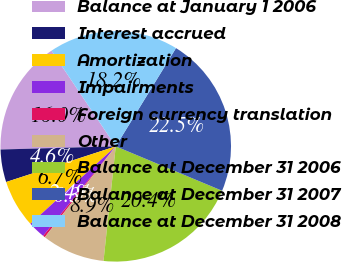<chart> <loc_0><loc_0><loc_500><loc_500><pie_chart><fcel>Balance at January 1 2006<fcel>Interest accrued<fcel>Amortization<fcel>Impairments<fcel>Foreign currency translation<fcel>Other<fcel>Balance at December 31 2006<fcel>Balance at December 31 2007<fcel>Balance at December 31 2008<nl><fcel>16.02%<fcel>4.57%<fcel>6.72%<fcel>2.43%<fcel>0.29%<fcel>8.86%<fcel>20.4%<fcel>22.54%<fcel>18.17%<nl></chart> 